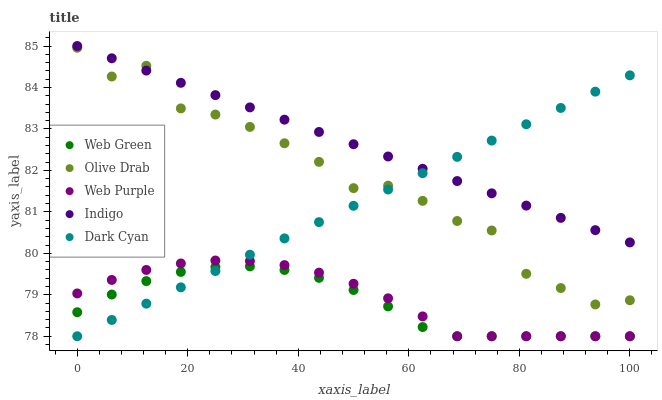Does Web Green have the minimum area under the curve?
Answer yes or no. Yes. Does Indigo have the maximum area under the curve?
Answer yes or no. Yes. Does Web Purple have the minimum area under the curve?
Answer yes or no. No. Does Web Purple have the maximum area under the curve?
Answer yes or no. No. Is Dark Cyan the smoothest?
Answer yes or no. Yes. Is Olive Drab the roughest?
Answer yes or no. Yes. Is Web Purple the smoothest?
Answer yes or no. No. Is Web Purple the roughest?
Answer yes or no. No. Does Dark Cyan have the lowest value?
Answer yes or no. Yes. Does Indigo have the lowest value?
Answer yes or no. No. Does Indigo have the highest value?
Answer yes or no. Yes. Does Web Purple have the highest value?
Answer yes or no. No. Is Web Purple less than Indigo?
Answer yes or no. Yes. Is Indigo greater than Web Purple?
Answer yes or no. Yes. Does Olive Drab intersect Dark Cyan?
Answer yes or no. Yes. Is Olive Drab less than Dark Cyan?
Answer yes or no. No. Is Olive Drab greater than Dark Cyan?
Answer yes or no. No. Does Web Purple intersect Indigo?
Answer yes or no. No. 